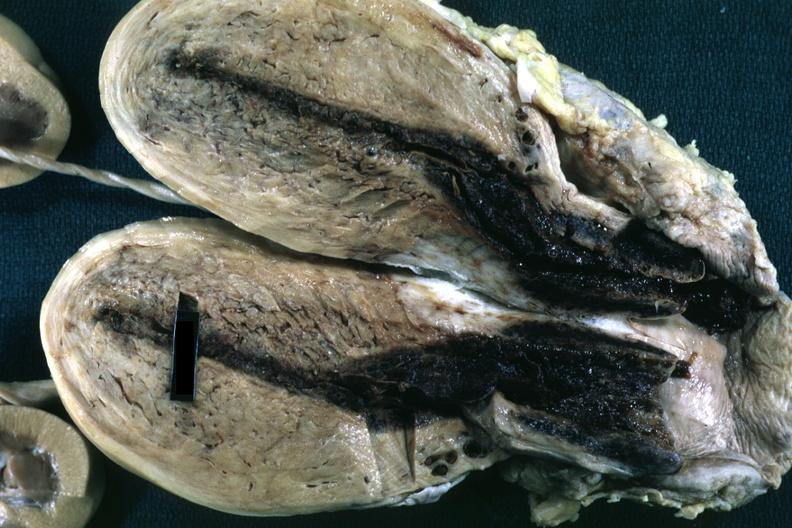what is present?
Answer the question using a single word or phrase. Postpartum uterus 